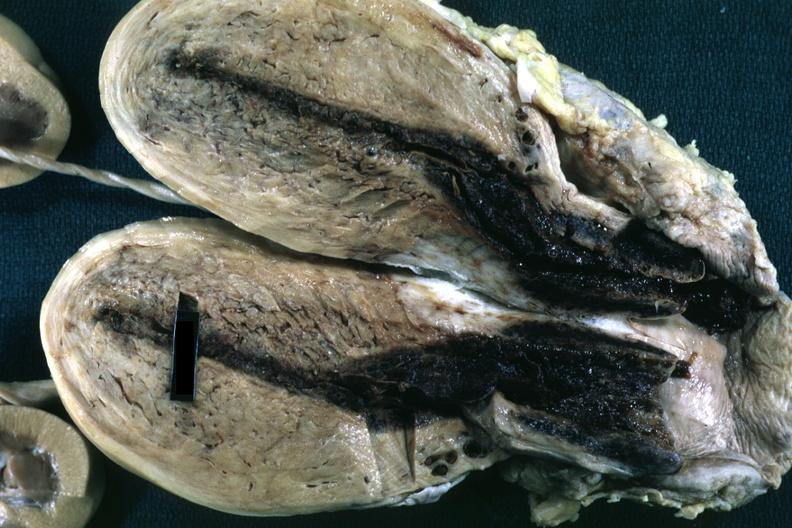what is present?
Answer the question using a single word or phrase. Postpartum uterus 